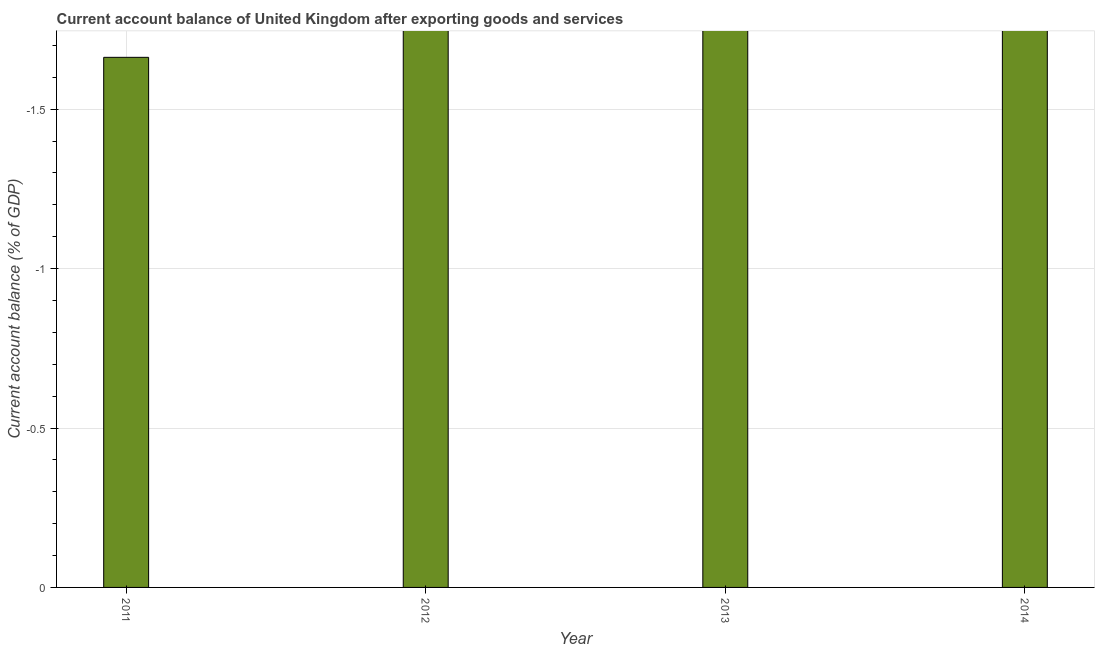Does the graph contain any zero values?
Your answer should be compact. Yes. Does the graph contain grids?
Offer a very short reply. Yes. What is the title of the graph?
Give a very brief answer. Current account balance of United Kingdom after exporting goods and services. What is the label or title of the Y-axis?
Your response must be concise. Current account balance (% of GDP). What is the sum of the current account balance?
Provide a short and direct response. 0. What is the average current account balance per year?
Provide a succinct answer. 0. Are all the bars in the graph horizontal?
Provide a succinct answer. No. What is the difference between two consecutive major ticks on the Y-axis?
Keep it short and to the point. 0.5. Are the values on the major ticks of Y-axis written in scientific E-notation?
Offer a very short reply. No. What is the Current account balance (% of GDP) of 2011?
Give a very brief answer. 0. What is the Current account balance (% of GDP) in 2012?
Make the answer very short. 0. What is the Current account balance (% of GDP) in 2014?
Offer a terse response. 0. 